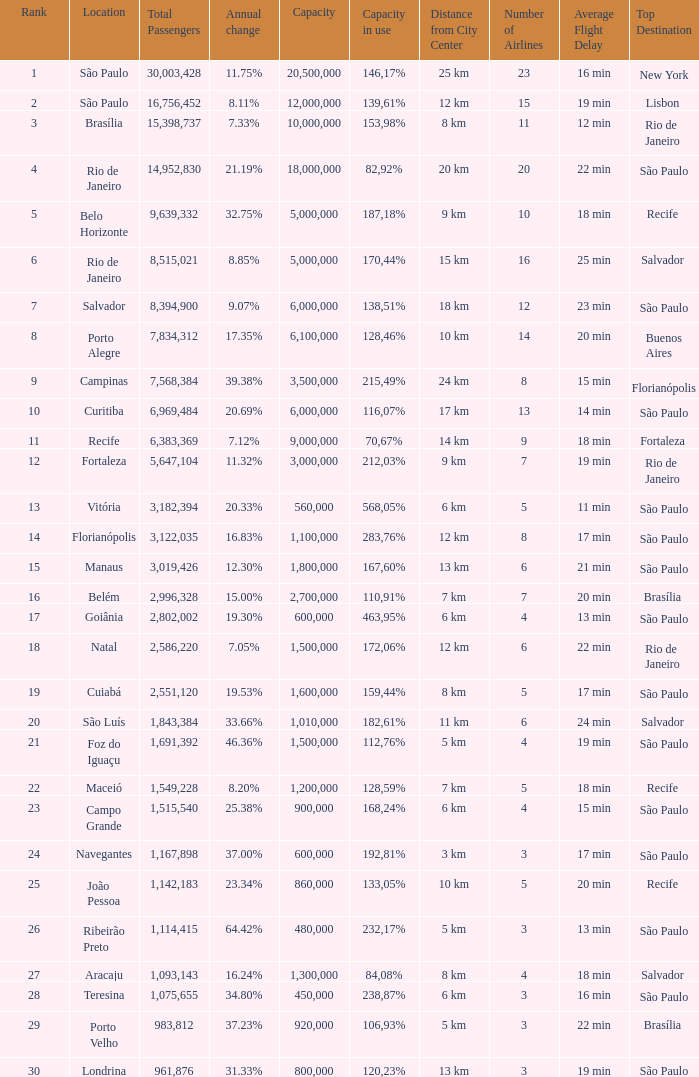Which location has a capacity that has a rank of 23? 168,24%. 